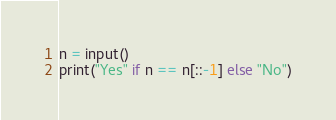<code> <loc_0><loc_0><loc_500><loc_500><_Python_>n = input()
print("Yes" if n == n[::-1] else "No")</code> 